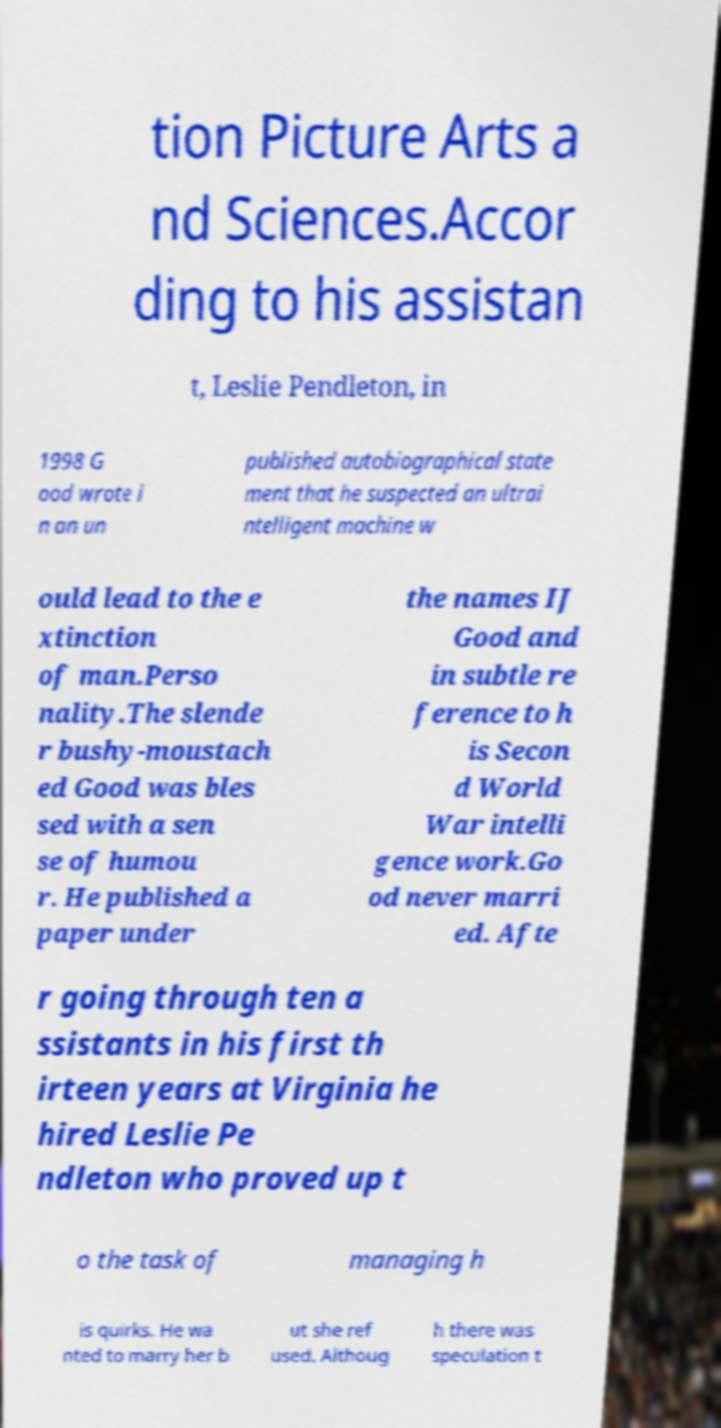What messages or text are displayed in this image? I need them in a readable, typed format. tion Picture Arts a nd Sciences.Accor ding to his assistan t, Leslie Pendleton, in 1998 G ood wrote i n an un published autobiographical state ment that he suspected an ultrai ntelligent machine w ould lead to the e xtinction of man.Perso nality.The slende r bushy-moustach ed Good was bles sed with a sen se of humou r. He published a paper under the names IJ Good and in subtle re ference to h is Secon d World War intelli gence work.Go od never marri ed. Afte r going through ten a ssistants in his first th irteen years at Virginia he hired Leslie Pe ndleton who proved up t o the task of managing h is quirks. He wa nted to marry her b ut she ref used. Althoug h there was speculation t 